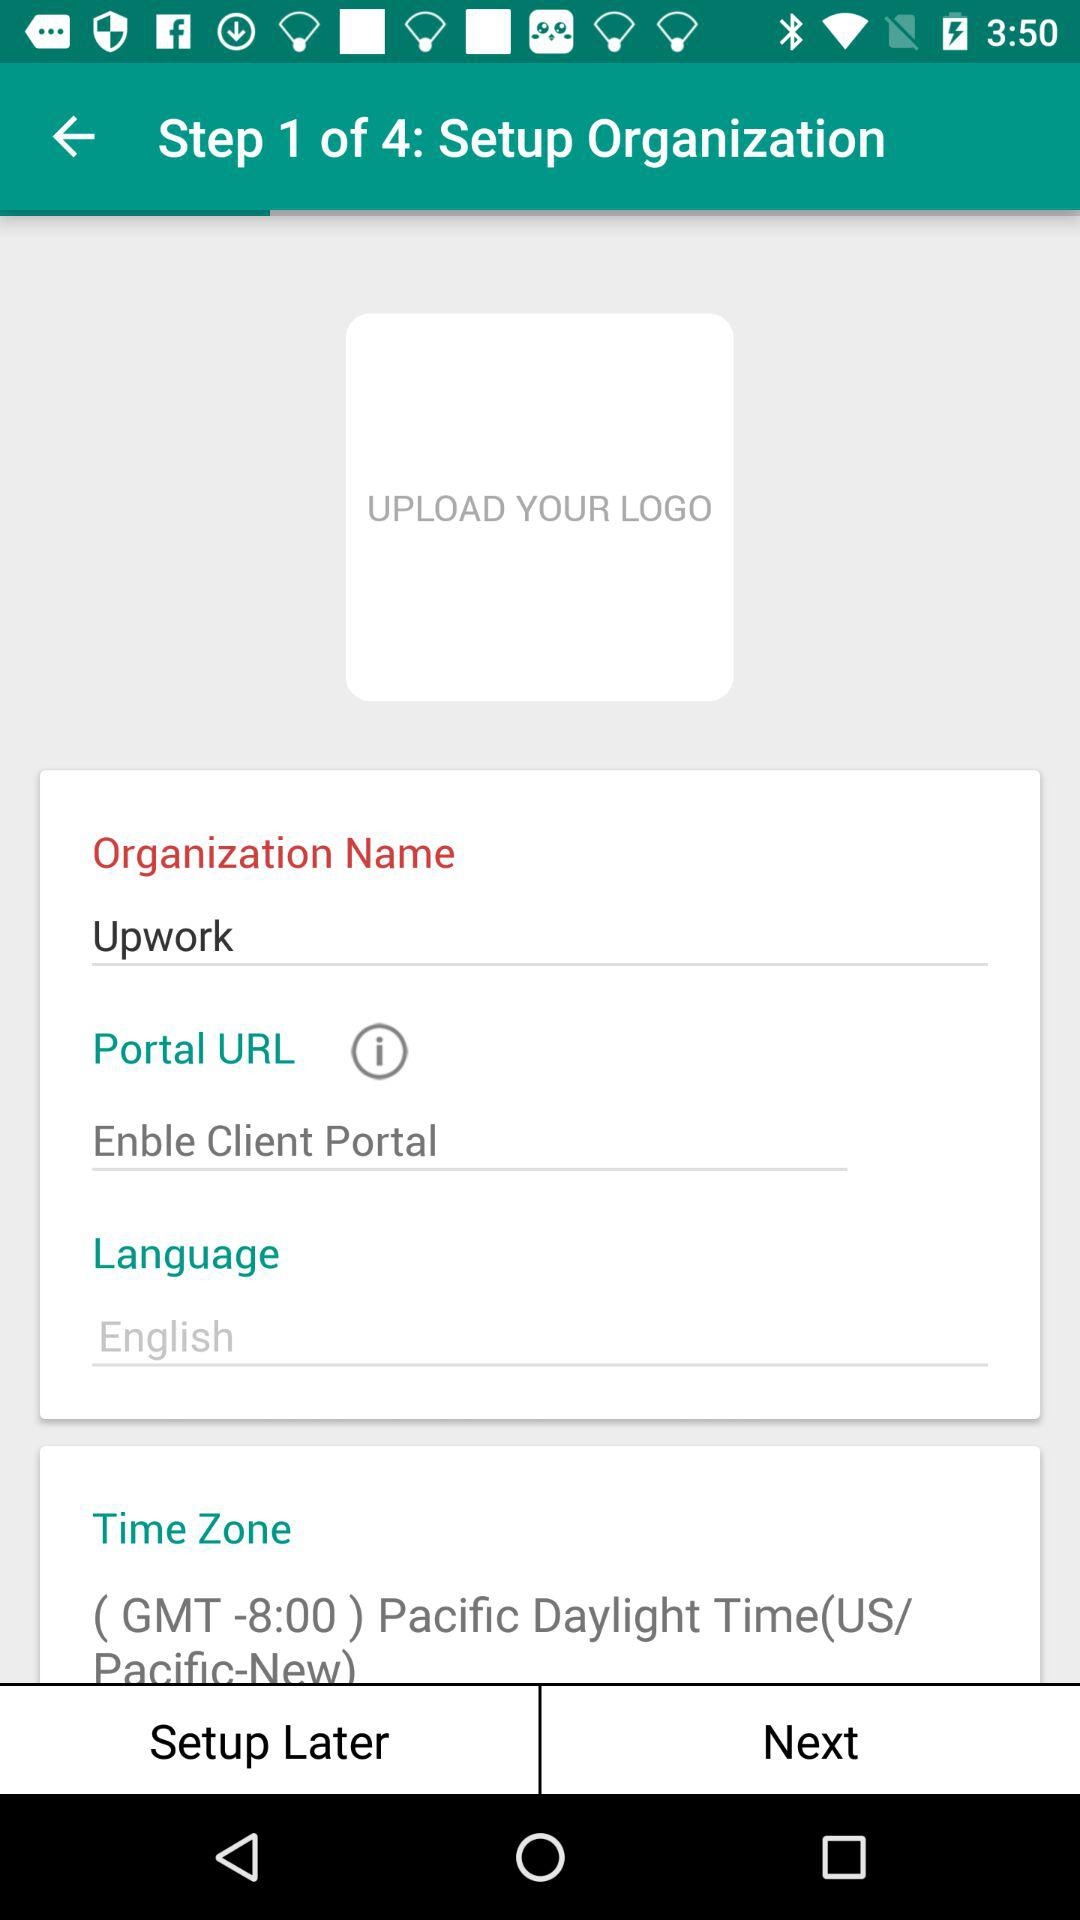What is the name of the organization? The name of the organization is "Upwork". 